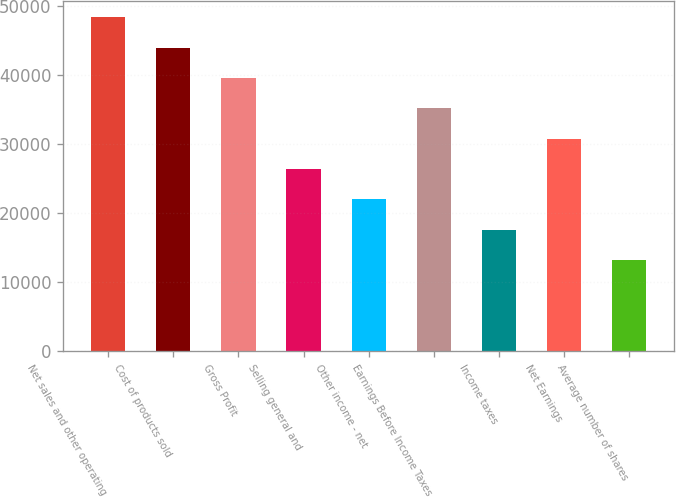Convert chart to OTSL. <chart><loc_0><loc_0><loc_500><loc_500><bar_chart><fcel>Net sales and other operating<fcel>Cost of products sold<fcel>Gross Profit<fcel>Selling general and<fcel>Other income - net<fcel>Earnings Before Income Taxes<fcel>Income taxes<fcel>Net Earnings<fcel>Average number of shares<nl><fcel>48419.5<fcel>44018<fcel>39616.5<fcel>26412.1<fcel>22010.7<fcel>35215.1<fcel>17609.2<fcel>30813.6<fcel>13207.7<nl></chart> 